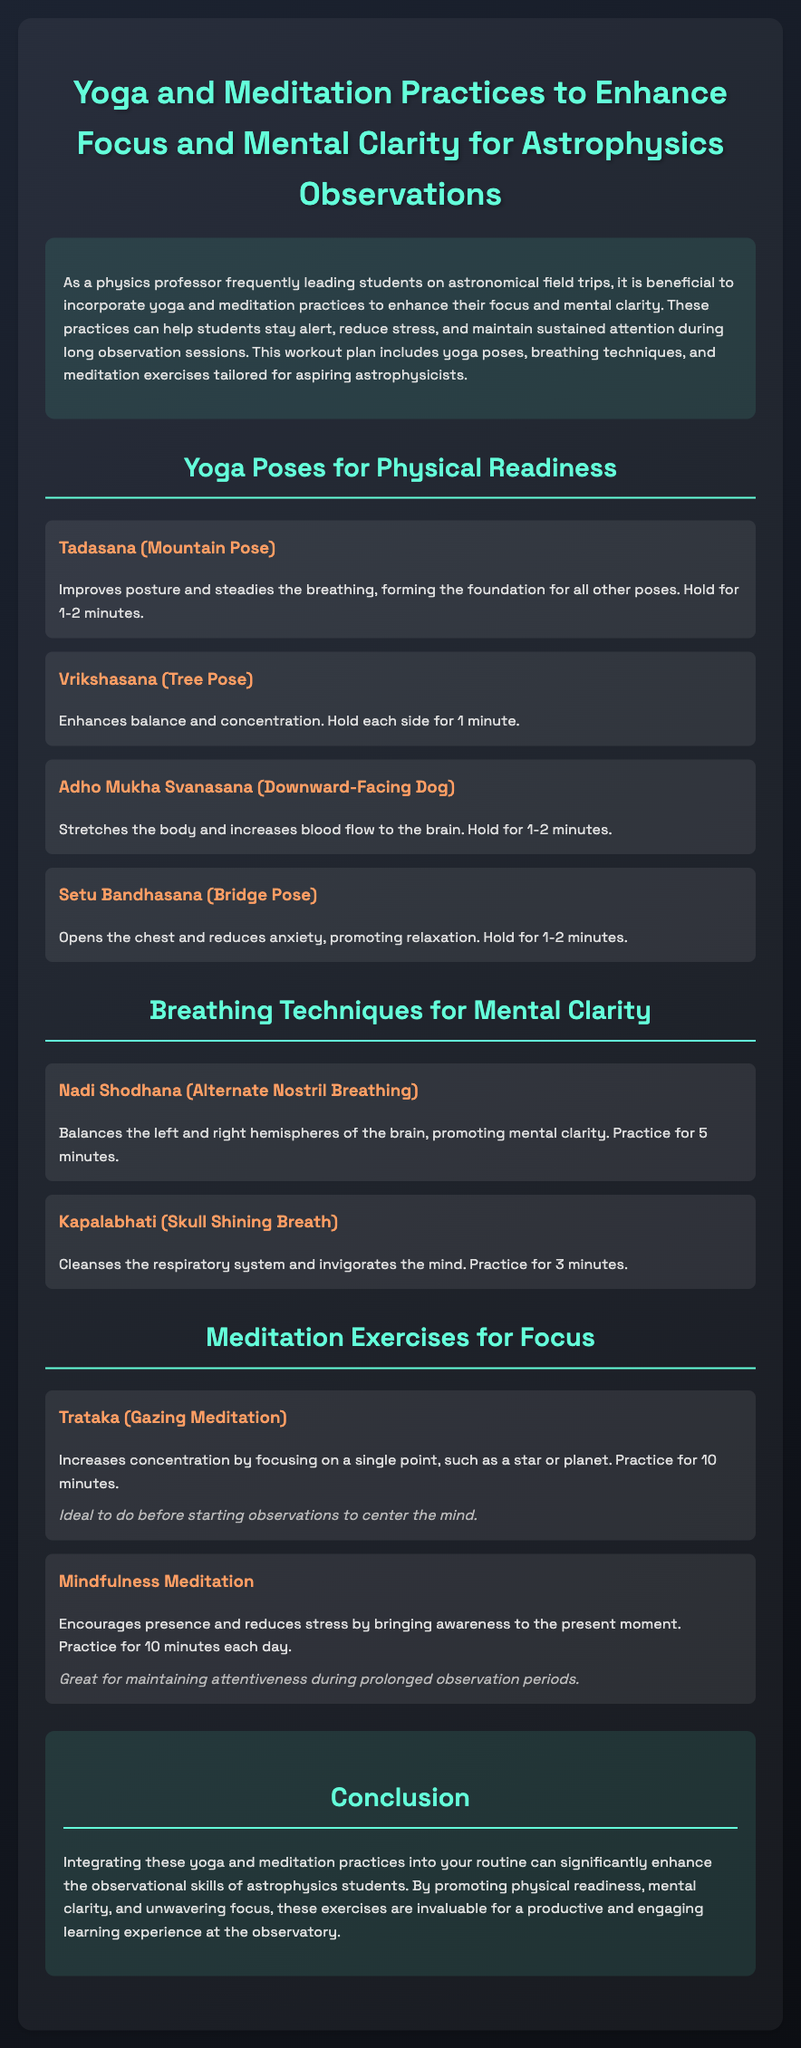What is the purpose of the workout plan? The purpose is to enhance focus and mental clarity for astrophysics observations.
Answer: Enhance focus and mental clarity How long should you hold Tadasana? The document specifies holding Tadasana for 1-2 minutes.
Answer: 1-2 minutes What breathing technique promotes mental clarity? Nadi Shodhana (Alternate Nostril Breathing) is mentioned as promoting mental clarity.
Answer: Nadi Shodhana What meditation exercise is ideal before starting observations? Trataka (Gazing Meditation) is identified as ideal to do before starting observations.
Answer: Trataka How long should mindfulness meditation be practiced daily? The document suggests practicing mindfulness meditation for 10 minutes each day.
Answer: 10 minutes What does Setu Bandhasana help reduce? Setu Bandhasana helps reduce anxiety.
Answer: Anxiety Which yoga pose enhances balance and concentration? Vrikshasana (Tree Pose) enhances balance and concentration.
Answer: Vrikshasana What is the effect of Kapalabhati? Kapalabhati cleanses the respiratory system and invigorates the mind.
Answer: Invigorates the mind What is the total number of yoga poses listed in the document? There are four yoga poses listed in the workout plan.
Answer: Four 